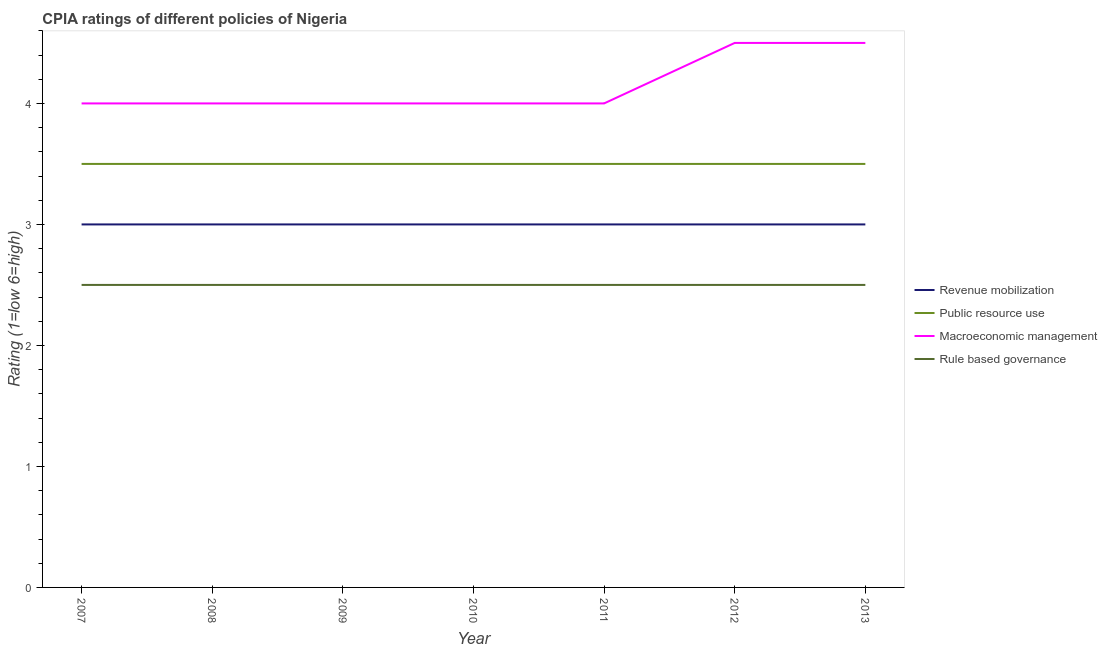How many different coloured lines are there?
Offer a terse response. 4. Is the number of lines equal to the number of legend labels?
Keep it short and to the point. Yes. What is the cpia rating of rule based governance in 2013?
Make the answer very short. 2.5. Across all years, what is the maximum cpia rating of macroeconomic management?
Offer a very short reply. 4.5. Across all years, what is the minimum cpia rating of macroeconomic management?
Your response must be concise. 4. In which year was the cpia rating of rule based governance maximum?
Your answer should be compact. 2007. What is the difference between the cpia rating of revenue mobilization in 2012 and the cpia rating of rule based governance in 2007?
Offer a very short reply. 0.5. In the year 2007, what is the difference between the cpia rating of revenue mobilization and cpia rating of rule based governance?
Provide a succinct answer. 0.5. In how many years, is the cpia rating of rule based governance greater than 1.6?
Your answer should be compact. 7. What is the ratio of the cpia rating of public resource use in 2010 to that in 2011?
Your answer should be very brief. 1. Is the cpia rating of public resource use in 2007 less than that in 2009?
Provide a succinct answer. No. Is the sum of the cpia rating of public resource use in 2007 and 2009 greater than the maximum cpia rating of revenue mobilization across all years?
Your response must be concise. Yes. Is it the case that in every year, the sum of the cpia rating of public resource use and cpia rating of rule based governance is greater than the sum of cpia rating of revenue mobilization and cpia rating of macroeconomic management?
Ensure brevity in your answer.  No. Is it the case that in every year, the sum of the cpia rating of revenue mobilization and cpia rating of public resource use is greater than the cpia rating of macroeconomic management?
Offer a terse response. Yes. Does the cpia rating of public resource use monotonically increase over the years?
Offer a very short reply. No. How many years are there in the graph?
Your response must be concise. 7. Are the values on the major ticks of Y-axis written in scientific E-notation?
Ensure brevity in your answer.  No. Does the graph contain any zero values?
Provide a short and direct response. No. Does the graph contain grids?
Offer a terse response. No. Where does the legend appear in the graph?
Provide a succinct answer. Center right. How many legend labels are there?
Offer a terse response. 4. How are the legend labels stacked?
Ensure brevity in your answer.  Vertical. What is the title of the graph?
Offer a terse response. CPIA ratings of different policies of Nigeria. What is the label or title of the Y-axis?
Offer a very short reply. Rating (1=low 6=high). What is the Rating (1=low 6=high) of Public resource use in 2007?
Provide a short and direct response. 3.5. What is the Rating (1=low 6=high) of Macroeconomic management in 2009?
Your answer should be compact. 4. What is the Rating (1=low 6=high) of Public resource use in 2010?
Your response must be concise. 3.5. What is the Rating (1=low 6=high) of Macroeconomic management in 2010?
Your answer should be very brief. 4. What is the Rating (1=low 6=high) in Rule based governance in 2010?
Ensure brevity in your answer.  2.5. What is the Rating (1=low 6=high) of Revenue mobilization in 2011?
Make the answer very short. 3. What is the Rating (1=low 6=high) in Public resource use in 2011?
Offer a terse response. 3.5. What is the Rating (1=low 6=high) of Rule based governance in 2011?
Offer a very short reply. 2.5. What is the Rating (1=low 6=high) in Revenue mobilization in 2012?
Keep it short and to the point. 3. What is the Rating (1=low 6=high) in Macroeconomic management in 2012?
Provide a succinct answer. 4.5. What is the Rating (1=low 6=high) of Rule based governance in 2012?
Make the answer very short. 2.5. What is the Rating (1=low 6=high) in Public resource use in 2013?
Provide a short and direct response. 3.5. Across all years, what is the maximum Rating (1=low 6=high) in Revenue mobilization?
Give a very brief answer. 3. Across all years, what is the minimum Rating (1=low 6=high) in Public resource use?
Ensure brevity in your answer.  3.5. What is the difference between the Rating (1=low 6=high) in Revenue mobilization in 2007 and that in 2008?
Offer a terse response. 0. What is the difference between the Rating (1=low 6=high) in Revenue mobilization in 2007 and that in 2009?
Your response must be concise. 0. What is the difference between the Rating (1=low 6=high) of Revenue mobilization in 2007 and that in 2010?
Offer a very short reply. 0. What is the difference between the Rating (1=low 6=high) of Public resource use in 2007 and that in 2010?
Offer a very short reply. 0. What is the difference between the Rating (1=low 6=high) of Macroeconomic management in 2007 and that in 2010?
Make the answer very short. 0. What is the difference between the Rating (1=low 6=high) of Revenue mobilization in 2007 and that in 2011?
Your answer should be compact. 0. What is the difference between the Rating (1=low 6=high) of Macroeconomic management in 2007 and that in 2011?
Your answer should be compact. 0. What is the difference between the Rating (1=low 6=high) of Rule based governance in 2007 and that in 2011?
Offer a very short reply. 0. What is the difference between the Rating (1=low 6=high) of Public resource use in 2007 and that in 2012?
Your answer should be very brief. 0. What is the difference between the Rating (1=low 6=high) in Macroeconomic management in 2007 and that in 2012?
Your response must be concise. -0.5. What is the difference between the Rating (1=low 6=high) of Revenue mobilization in 2007 and that in 2013?
Your answer should be compact. 0. What is the difference between the Rating (1=low 6=high) of Public resource use in 2007 and that in 2013?
Give a very brief answer. 0. What is the difference between the Rating (1=low 6=high) in Macroeconomic management in 2007 and that in 2013?
Give a very brief answer. -0.5. What is the difference between the Rating (1=low 6=high) of Rule based governance in 2007 and that in 2013?
Keep it short and to the point. 0. What is the difference between the Rating (1=low 6=high) of Public resource use in 2008 and that in 2009?
Offer a very short reply. 0. What is the difference between the Rating (1=low 6=high) in Revenue mobilization in 2008 and that in 2010?
Your answer should be very brief. 0. What is the difference between the Rating (1=low 6=high) in Public resource use in 2008 and that in 2010?
Keep it short and to the point. 0. What is the difference between the Rating (1=low 6=high) of Macroeconomic management in 2008 and that in 2010?
Give a very brief answer. 0. What is the difference between the Rating (1=low 6=high) of Public resource use in 2008 and that in 2011?
Provide a short and direct response. 0. What is the difference between the Rating (1=low 6=high) of Macroeconomic management in 2008 and that in 2011?
Your answer should be very brief. 0. What is the difference between the Rating (1=low 6=high) in Rule based governance in 2008 and that in 2011?
Offer a very short reply. 0. What is the difference between the Rating (1=low 6=high) in Public resource use in 2008 and that in 2012?
Ensure brevity in your answer.  0. What is the difference between the Rating (1=low 6=high) of Public resource use in 2008 and that in 2013?
Your answer should be very brief. 0. What is the difference between the Rating (1=low 6=high) in Macroeconomic management in 2008 and that in 2013?
Your response must be concise. -0.5. What is the difference between the Rating (1=low 6=high) of Revenue mobilization in 2009 and that in 2010?
Offer a terse response. 0. What is the difference between the Rating (1=low 6=high) in Rule based governance in 2009 and that in 2010?
Make the answer very short. 0. What is the difference between the Rating (1=low 6=high) of Revenue mobilization in 2009 and that in 2011?
Your answer should be very brief. 0. What is the difference between the Rating (1=low 6=high) of Public resource use in 2009 and that in 2011?
Ensure brevity in your answer.  0. What is the difference between the Rating (1=low 6=high) of Revenue mobilization in 2009 and that in 2012?
Ensure brevity in your answer.  0. What is the difference between the Rating (1=low 6=high) of Public resource use in 2009 and that in 2012?
Offer a very short reply. 0. What is the difference between the Rating (1=low 6=high) of Macroeconomic management in 2009 and that in 2012?
Your answer should be compact. -0.5. What is the difference between the Rating (1=low 6=high) of Rule based governance in 2009 and that in 2012?
Provide a short and direct response. 0. What is the difference between the Rating (1=low 6=high) of Public resource use in 2009 and that in 2013?
Your answer should be very brief. 0. What is the difference between the Rating (1=low 6=high) in Macroeconomic management in 2009 and that in 2013?
Give a very brief answer. -0.5. What is the difference between the Rating (1=low 6=high) in Rule based governance in 2009 and that in 2013?
Your response must be concise. 0. What is the difference between the Rating (1=low 6=high) of Revenue mobilization in 2010 and that in 2011?
Ensure brevity in your answer.  0. What is the difference between the Rating (1=low 6=high) of Revenue mobilization in 2010 and that in 2012?
Offer a very short reply. 0. What is the difference between the Rating (1=low 6=high) of Macroeconomic management in 2010 and that in 2012?
Keep it short and to the point. -0.5. What is the difference between the Rating (1=low 6=high) of Rule based governance in 2010 and that in 2012?
Make the answer very short. 0. What is the difference between the Rating (1=low 6=high) in Revenue mobilization in 2010 and that in 2013?
Provide a short and direct response. 0. What is the difference between the Rating (1=low 6=high) of Public resource use in 2010 and that in 2013?
Give a very brief answer. 0. What is the difference between the Rating (1=low 6=high) in Macroeconomic management in 2010 and that in 2013?
Make the answer very short. -0.5. What is the difference between the Rating (1=low 6=high) in Rule based governance in 2010 and that in 2013?
Offer a terse response. 0. What is the difference between the Rating (1=low 6=high) in Public resource use in 2011 and that in 2012?
Offer a very short reply. 0. What is the difference between the Rating (1=low 6=high) of Macroeconomic management in 2011 and that in 2012?
Offer a very short reply. -0.5. What is the difference between the Rating (1=low 6=high) of Public resource use in 2011 and that in 2013?
Your answer should be compact. 0. What is the difference between the Rating (1=low 6=high) in Rule based governance in 2011 and that in 2013?
Give a very brief answer. 0. What is the difference between the Rating (1=low 6=high) in Public resource use in 2012 and that in 2013?
Provide a short and direct response. 0. What is the difference between the Rating (1=low 6=high) of Revenue mobilization in 2007 and the Rating (1=low 6=high) of Public resource use in 2008?
Provide a short and direct response. -0.5. What is the difference between the Rating (1=low 6=high) in Revenue mobilization in 2007 and the Rating (1=low 6=high) in Rule based governance in 2008?
Offer a terse response. 0.5. What is the difference between the Rating (1=low 6=high) in Public resource use in 2007 and the Rating (1=low 6=high) in Macroeconomic management in 2008?
Your response must be concise. -0.5. What is the difference between the Rating (1=low 6=high) in Public resource use in 2007 and the Rating (1=low 6=high) in Macroeconomic management in 2009?
Ensure brevity in your answer.  -0.5. What is the difference between the Rating (1=low 6=high) in Public resource use in 2007 and the Rating (1=low 6=high) in Rule based governance in 2009?
Your answer should be compact. 1. What is the difference between the Rating (1=low 6=high) of Macroeconomic management in 2007 and the Rating (1=low 6=high) of Rule based governance in 2009?
Keep it short and to the point. 1.5. What is the difference between the Rating (1=low 6=high) in Revenue mobilization in 2007 and the Rating (1=low 6=high) in Public resource use in 2010?
Ensure brevity in your answer.  -0.5. What is the difference between the Rating (1=low 6=high) of Revenue mobilization in 2007 and the Rating (1=low 6=high) of Macroeconomic management in 2010?
Your response must be concise. -1. What is the difference between the Rating (1=low 6=high) of Macroeconomic management in 2007 and the Rating (1=low 6=high) of Rule based governance in 2010?
Make the answer very short. 1.5. What is the difference between the Rating (1=low 6=high) of Macroeconomic management in 2007 and the Rating (1=low 6=high) of Rule based governance in 2011?
Offer a very short reply. 1.5. What is the difference between the Rating (1=low 6=high) in Revenue mobilization in 2007 and the Rating (1=low 6=high) in Public resource use in 2012?
Provide a succinct answer. -0.5. What is the difference between the Rating (1=low 6=high) of Revenue mobilization in 2007 and the Rating (1=low 6=high) of Rule based governance in 2012?
Ensure brevity in your answer.  0.5. What is the difference between the Rating (1=low 6=high) of Revenue mobilization in 2007 and the Rating (1=low 6=high) of Rule based governance in 2013?
Your answer should be very brief. 0.5. What is the difference between the Rating (1=low 6=high) in Public resource use in 2007 and the Rating (1=low 6=high) in Macroeconomic management in 2013?
Give a very brief answer. -1. What is the difference between the Rating (1=low 6=high) of Public resource use in 2007 and the Rating (1=low 6=high) of Rule based governance in 2013?
Offer a terse response. 1. What is the difference between the Rating (1=low 6=high) in Public resource use in 2008 and the Rating (1=low 6=high) in Rule based governance in 2009?
Keep it short and to the point. 1. What is the difference between the Rating (1=low 6=high) in Macroeconomic management in 2008 and the Rating (1=low 6=high) in Rule based governance in 2009?
Your answer should be very brief. 1.5. What is the difference between the Rating (1=low 6=high) in Revenue mobilization in 2008 and the Rating (1=low 6=high) in Rule based governance in 2010?
Offer a terse response. 0.5. What is the difference between the Rating (1=low 6=high) of Public resource use in 2008 and the Rating (1=low 6=high) of Macroeconomic management in 2010?
Keep it short and to the point. -0.5. What is the difference between the Rating (1=low 6=high) in Macroeconomic management in 2008 and the Rating (1=low 6=high) in Rule based governance in 2010?
Your answer should be compact. 1.5. What is the difference between the Rating (1=low 6=high) in Revenue mobilization in 2008 and the Rating (1=low 6=high) in Public resource use in 2011?
Your answer should be compact. -0.5. What is the difference between the Rating (1=low 6=high) in Revenue mobilization in 2008 and the Rating (1=low 6=high) in Macroeconomic management in 2011?
Make the answer very short. -1. What is the difference between the Rating (1=low 6=high) in Public resource use in 2008 and the Rating (1=low 6=high) in Macroeconomic management in 2011?
Make the answer very short. -0.5. What is the difference between the Rating (1=low 6=high) of Macroeconomic management in 2008 and the Rating (1=low 6=high) of Rule based governance in 2011?
Offer a very short reply. 1.5. What is the difference between the Rating (1=low 6=high) in Public resource use in 2008 and the Rating (1=low 6=high) in Macroeconomic management in 2012?
Give a very brief answer. -1. What is the difference between the Rating (1=low 6=high) in Public resource use in 2008 and the Rating (1=low 6=high) in Rule based governance in 2012?
Give a very brief answer. 1. What is the difference between the Rating (1=low 6=high) in Macroeconomic management in 2008 and the Rating (1=low 6=high) in Rule based governance in 2012?
Provide a succinct answer. 1.5. What is the difference between the Rating (1=low 6=high) of Revenue mobilization in 2008 and the Rating (1=low 6=high) of Macroeconomic management in 2013?
Your response must be concise. -1.5. What is the difference between the Rating (1=low 6=high) in Revenue mobilization in 2008 and the Rating (1=low 6=high) in Rule based governance in 2013?
Your answer should be compact. 0.5. What is the difference between the Rating (1=low 6=high) in Public resource use in 2008 and the Rating (1=low 6=high) in Macroeconomic management in 2013?
Ensure brevity in your answer.  -1. What is the difference between the Rating (1=low 6=high) of Public resource use in 2008 and the Rating (1=low 6=high) of Rule based governance in 2013?
Offer a terse response. 1. What is the difference between the Rating (1=low 6=high) of Revenue mobilization in 2009 and the Rating (1=low 6=high) of Macroeconomic management in 2010?
Give a very brief answer. -1. What is the difference between the Rating (1=low 6=high) in Public resource use in 2009 and the Rating (1=low 6=high) in Macroeconomic management in 2010?
Provide a succinct answer. -0.5. What is the difference between the Rating (1=low 6=high) in Public resource use in 2009 and the Rating (1=low 6=high) in Rule based governance in 2010?
Keep it short and to the point. 1. What is the difference between the Rating (1=low 6=high) in Revenue mobilization in 2009 and the Rating (1=low 6=high) in Public resource use in 2011?
Your response must be concise. -0.5. What is the difference between the Rating (1=low 6=high) in Revenue mobilization in 2009 and the Rating (1=low 6=high) in Rule based governance in 2011?
Keep it short and to the point. 0.5. What is the difference between the Rating (1=low 6=high) of Macroeconomic management in 2009 and the Rating (1=low 6=high) of Rule based governance in 2011?
Give a very brief answer. 1.5. What is the difference between the Rating (1=low 6=high) in Revenue mobilization in 2009 and the Rating (1=low 6=high) in Public resource use in 2012?
Provide a short and direct response. -0.5. What is the difference between the Rating (1=low 6=high) in Revenue mobilization in 2009 and the Rating (1=low 6=high) in Macroeconomic management in 2012?
Provide a succinct answer. -1.5. What is the difference between the Rating (1=low 6=high) in Revenue mobilization in 2009 and the Rating (1=low 6=high) in Rule based governance in 2012?
Give a very brief answer. 0.5. What is the difference between the Rating (1=low 6=high) in Public resource use in 2009 and the Rating (1=low 6=high) in Macroeconomic management in 2012?
Ensure brevity in your answer.  -1. What is the difference between the Rating (1=low 6=high) in Macroeconomic management in 2009 and the Rating (1=low 6=high) in Rule based governance in 2012?
Ensure brevity in your answer.  1.5. What is the difference between the Rating (1=low 6=high) in Revenue mobilization in 2009 and the Rating (1=low 6=high) in Rule based governance in 2013?
Your response must be concise. 0.5. What is the difference between the Rating (1=low 6=high) of Macroeconomic management in 2009 and the Rating (1=low 6=high) of Rule based governance in 2013?
Offer a very short reply. 1.5. What is the difference between the Rating (1=low 6=high) of Revenue mobilization in 2010 and the Rating (1=low 6=high) of Public resource use in 2011?
Your answer should be very brief. -0.5. What is the difference between the Rating (1=low 6=high) of Revenue mobilization in 2010 and the Rating (1=low 6=high) of Macroeconomic management in 2011?
Your answer should be very brief. -1. What is the difference between the Rating (1=low 6=high) of Revenue mobilization in 2010 and the Rating (1=low 6=high) of Rule based governance in 2011?
Give a very brief answer. 0.5. What is the difference between the Rating (1=low 6=high) of Revenue mobilization in 2010 and the Rating (1=low 6=high) of Public resource use in 2012?
Keep it short and to the point. -0.5. What is the difference between the Rating (1=low 6=high) of Macroeconomic management in 2010 and the Rating (1=low 6=high) of Rule based governance in 2012?
Your answer should be compact. 1.5. What is the difference between the Rating (1=low 6=high) of Revenue mobilization in 2010 and the Rating (1=low 6=high) of Public resource use in 2013?
Your response must be concise. -0.5. What is the difference between the Rating (1=low 6=high) in Public resource use in 2010 and the Rating (1=low 6=high) in Macroeconomic management in 2013?
Your answer should be compact. -1. What is the difference between the Rating (1=low 6=high) in Public resource use in 2010 and the Rating (1=low 6=high) in Rule based governance in 2013?
Provide a succinct answer. 1. What is the difference between the Rating (1=low 6=high) of Revenue mobilization in 2011 and the Rating (1=low 6=high) of Public resource use in 2012?
Your response must be concise. -0.5. What is the difference between the Rating (1=low 6=high) of Revenue mobilization in 2011 and the Rating (1=low 6=high) of Rule based governance in 2012?
Give a very brief answer. 0.5. What is the difference between the Rating (1=low 6=high) in Public resource use in 2011 and the Rating (1=low 6=high) in Macroeconomic management in 2012?
Give a very brief answer. -1. What is the difference between the Rating (1=low 6=high) of Macroeconomic management in 2011 and the Rating (1=low 6=high) of Rule based governance in 2012?
Make the answer very short. 1.5. What is the difference between the Rating (1=low 6=high) of Revenue mobilization in 2011 and the Rating (1=low 6=high) of Public resource use in 2013?
Give a very brief answer. -0.5. What is the difference between the Rating (1=low 6=high) of Revenue mobilization in 2011 and the Rating (1=low 6=high) of Rule based governance in 2013?
Give a very brief answer. 0.5. What is the difference between the Rating (1=low 6=high) of Public resource use in 2011 and the Rating (1=low 6=high) of Rule based governance in 2013?
Your answer should be compact. 1. What is the difference between the Rating (1=low 6=high) of Revenue mobilization in 2012 and the Rating (1=low 6=high) of Public resource use in 2013?
Make the answer very short. -0.5. What is the difference between the Rating (1=low 6=high) of Revenue mobilization in 2012 and the Rating (1=low 6=high) of Rule based governance in 2013?
Make the answer very short. 0.5. What is the difference between the Rating (1=low 6=high) in Public resource use in 2012 and the Rating (1=low 6=high) in Rule based governance in 2013?
Provide a short and direct response. 1. What is the difference between the Rating (1=low 6=high) in Macroeconomic management in 2012 and the Rating (1=low 6=high) in Rule based governance in 2013?
Make the answer very short. 2. What is the average Rating (1=low 6=high) of Public resource use per year?
Your answer should be compact. 3.5. What is the average Rating (1=low 6=high) of Macroeconomic management per year?
Make the answer very short. 4.14. What is the average Rating (1=low 6=high) in Rule based governance per year?
Offer a very short reply. 2.5. In the year 2007, what is the difference between the Rating (1=low 6=high) of Revenue mobilization and Rating (1=low 6=high) of Public resource use?
Keep it short and to the point. -0.5. In the year 2007, what is the difference between the Rating (1=low 6=high) of Revenue mobilization and Rating (1=low 6=high) of Macroeconomic management?
Give a very brief answer. -1. In the year 2007, what is the difference between the Rating (1=low 6=high) of Public resource use and Rating (1=low 6=high) of Macroeconomic management?
Ensure brevity in your answer.  -0.5. In the year 2007, what is the difference between the Rating (1=low 6=high) in Public resource use and Rating (1=low 6=high) in Rule based governance?
Ensure brevity in your answer.  1. In the year 2008, what is the difference between the Rating (1=low 6=high) in Revenue mobilization and Rating (1=low 6=high) in Public resource use?
Offer a very short reply. -0.5. In the year 2008, what is the difference between the Rating (1=low 6=high) in Public resource use and Rating (1=low 6=high) in Rule based governance?
Your response must be concise. 1. In the year 2009, what is the difference between the Rating (1=low 6=high) in Revenue mobilization and Rating (1=low 6=high) in Public resource use?
Your answer should be compact. -0.5. In the year 2009, what is the difference between the Rating (1=low 6=high) of Public resource use and Rating (1=low 6=high) of Macroeconomic management?
Ensure brevity in your answer.  -0.5. In the year 2009, what is the difference between the Rating (1=low 6=high) in Macroeconomic management and Rating (1=low 6=high) in Rule based governance?
Your answer should be very brief. 1.5. In the year 2010, what is the difference between the Rating (1=low 6=high) of Revenue mobilization and Rating (1=low 6=high) of Public resource use?
Provide a succinct answer. -0.5. In the year 2010, what is the difference between the Rating (1=low 6=high) in Revenue mobilization and Rating (1=low 6=high) in Macroeconomic management?
Provide a succinct answer. -1. In the year 2010, what is the difference between the Rating (1=low 6=high) in Public resource use and Rating (1=low 6=high) in Macroeconomic management?
Make the answer very short. -0.5. In the year 2010, what is the difference between the Rating (1=low 6=high) in Macroeconomic management and Rating (1=low 6=high) in Rule based governance?
Your answer should be very brief. 1.5. In the year 2011, what is the difference between the Rating (1=low 6=high) of Revenue mobilization and Rating (1=low 6=high) of Macroeconomic management?
Your response must be concise. -1. In the year 2012, what is the difference between the Rating (1=low 6=high) in Revenue mobilization and Rating (1=low 6=high) in Public resource use?
Make the answer very short. -0.5. In the year 2012, what is the difference between the Rating (1=low 6=high) of Public resource use and Rating (1=low 6=high) of Rule based governance?
Your response must be concise. 1. In the year 2013, what is the difference between the Rating (1=low 6=high) in Revenue mobilization and Rating (1=low 6=high) in Rule based governance?
Give a very brief answer. 0.5. What is the ratio of the Rating (1=low 6=high) of Public resource use in 2007 to that in 2008?
Your answer should be compact. 1. What is the ratio of the Rating (1=low 6=high) in Macroeconomic management in 2007 to that in 2008?
Give a very brief answer. 1. What is the ratio of the Rating (1=low 6=high) in Revenue mobilization in 2007 to that in 2009?
Give a very brief answer. 1. What is the ratio of the Rating (1=low 6=high) of Macroeconomic management in 2007 to that in 2009?
Offer a terse response. 1. What is the ratio of the Rating (1=low 6=high) in Macroeconomic management in 2007 to that in 2010?
Provide a succinct answer. 1. What is the ratio of the Rating (1=low 6=high) in Rule based governance in 2007 to that in 2010?
Give a very brief answer. 1. What is the ratio of the Rating (1=low 6=high) of Public resource use in 2007 to that in 2011?
Ensure brevity in your answer.  1. What is the ratio of the Rating (1=low 6=high) in Revenue mobilization in 2007 to that in 2012?
Your answer should be compact. 1. What is the ratio of the Rating (1=low 6=high) in Macroeconomic management in 2007 to that in 2012?
Keep it short and to the point. 0.89. What is the ratio of the Rating (1=low 6=high) in Revenue mobilization in 2007 to that in 2013?
Make the answer very short. 1. What is the ratio of the Rating (1=low 6=high) in Public resource use in 2007 to that in 2013?
Your answer should be very brief. 1. What is the ratio of the Rating (1=low 6=high) of Rule based governance in 2007 to that in 2013?
Give a very brief answer. 1. What is the ratio of the Rating (1=low 6=high) of Macroeconomic management in 2008 to that in 2009?
Make the answer very short. 1. What is the ratio of the Rating (1=low 6=high) in Rule based governance in 2008 to that in 2009?
Your answer should be compact. 1. What is the ratio of the Rating (1=low 6=high) in Revenue mobilization in 2008 to that in 2010?
Your answer should be very brief. 1. What is the ratio of the Rating (1=low 6=high) of Macroeconomic management in 2008 to that in 2010?
Keep it short and to the point. 1. What is the ratio of the Rating (1=low 6=high) of Rule based governance in 2008 to that in 2010?
Offer a terse response. 1. What is the ratio of the Rating (1=low 6=high) of Macroeconomic management in 2008 to that in 2011?
Your answer should be compact. 1. What is the ratio of the Rating (1=low 6=high) in Macroeconomic management in 2008 to that in 2012?
Keep it short and to the point. 0.89. What is the ratio of the Rating (1=low 6=high) of Revenue mobilization in 2008 to that in 2013?
Your answer should be very brief. 1. What is the ratio of the Rating (1=low 6=high) in Macroeconomic management in 2008 to that in 2013?
Make the answer very short. 0.89. What is the ratio of the Rating (1=low 6=high) of Rule based governance in 2008 to that in 2013?
Your response must be concise. 1. What is the ratio of the Rating (1=low 6=high) of Revenue mobilization in 2009 to that in 2010?
Give a very brief answer. 1. What is the ratio of the Rating (1=low 6=high) in Public resource use in 2009 to that in 2010?
Ensure brevity in your answer.  1. What is the ratio of the Rating (1=low 6=high) in Rule based governance in 2009 to that in 2010?
Your response must be concise. 1. What is the ratio of the Rating (1=low 6=high) of Macroeconomic management in 2009 to that in 2011?
Provide a succinct answer. 1. What is the ratio of the Rating (1=low 6=high) in Macroeconomic management in 2009 to that in 2012?
Offer a terse response. 0.89. What is the ratio of the Rating (1=low 6=high) in Rule based governance in 2009 to that in 2012?
Provide a short and direct response. 1. What is the ratio of the Rating (1=low 6=high) of Revenue mobilization in 2009 to that in 2013?
Give a very brief answer. 1. What is the ratio of the Rating (1=low 6=high) of Macroeconomic management in 2009 to that in 2013?
Offer a very short reply. 0.89. What is the ratio of the Rating (1=low 6=high) in Rule based governance in 2009 to that in 2013?
Keep it short and to the point. 1. What is the ratio of the Rating (1=low 6=high) in Macroeconomic management in 2010 to that in 2011?
Offer a terse response. 1. What is the ratio of the Rating (1=low 6=high) of Public resource use in 2010 to that in 2012?
Your answer should be very brief. 1. What is the ratio of the Rating (1=low 6=high) of Revenue mobilization in 2010 to that in 2013?
Your response must be concise. 1. What is the ratio of the Rating (1=low 6=high) of Macroeconomic management in 2010 to that in 2013?
Give a very brief answer. 0.89. What is the ratio of the Rating (1=low 6=high) of Rule based governance in 2010 to that in 2013?
Provide a succinct answer. 1. What is the ratio of the Rating (1=low 6=high) of Macroeconomic management in 2011 to that in 2012?
Keep it short and to the point. 0.89. What is the ratio of the Rating (1=low 6=high) of Rule based governance in 2011 to that in 2012?
Ensure brevity in your answer.  1. What is the ratio of the Rating (1=low 6=high) in Macroeconomic management in 2011 to that in 2013?
Keep it short and to the point. 0.89. What is the ratio of the Rating (1=low 6=high) of Revenue mobilization in 2012 to that in 2013?
Your answer should be compact. 1. What is the difference between the highest and the second highest Rating (1=low 6=high) in Macroeconomic management?
Offer a very short reply. 0. What is the difference between the highest and the lowest Rating (1=low 6=high) of Public resource use?
Offer a very short reply. 0. What is the difference between the highest and the lowest Rating (1=low 6=high) of Macroeconomic management?
Give a very brief answer. 0.5. What is the difference between the highest and the lowest Rating (1=low 6=high) of Rule based governance?
Offer a very short reply. 0. 